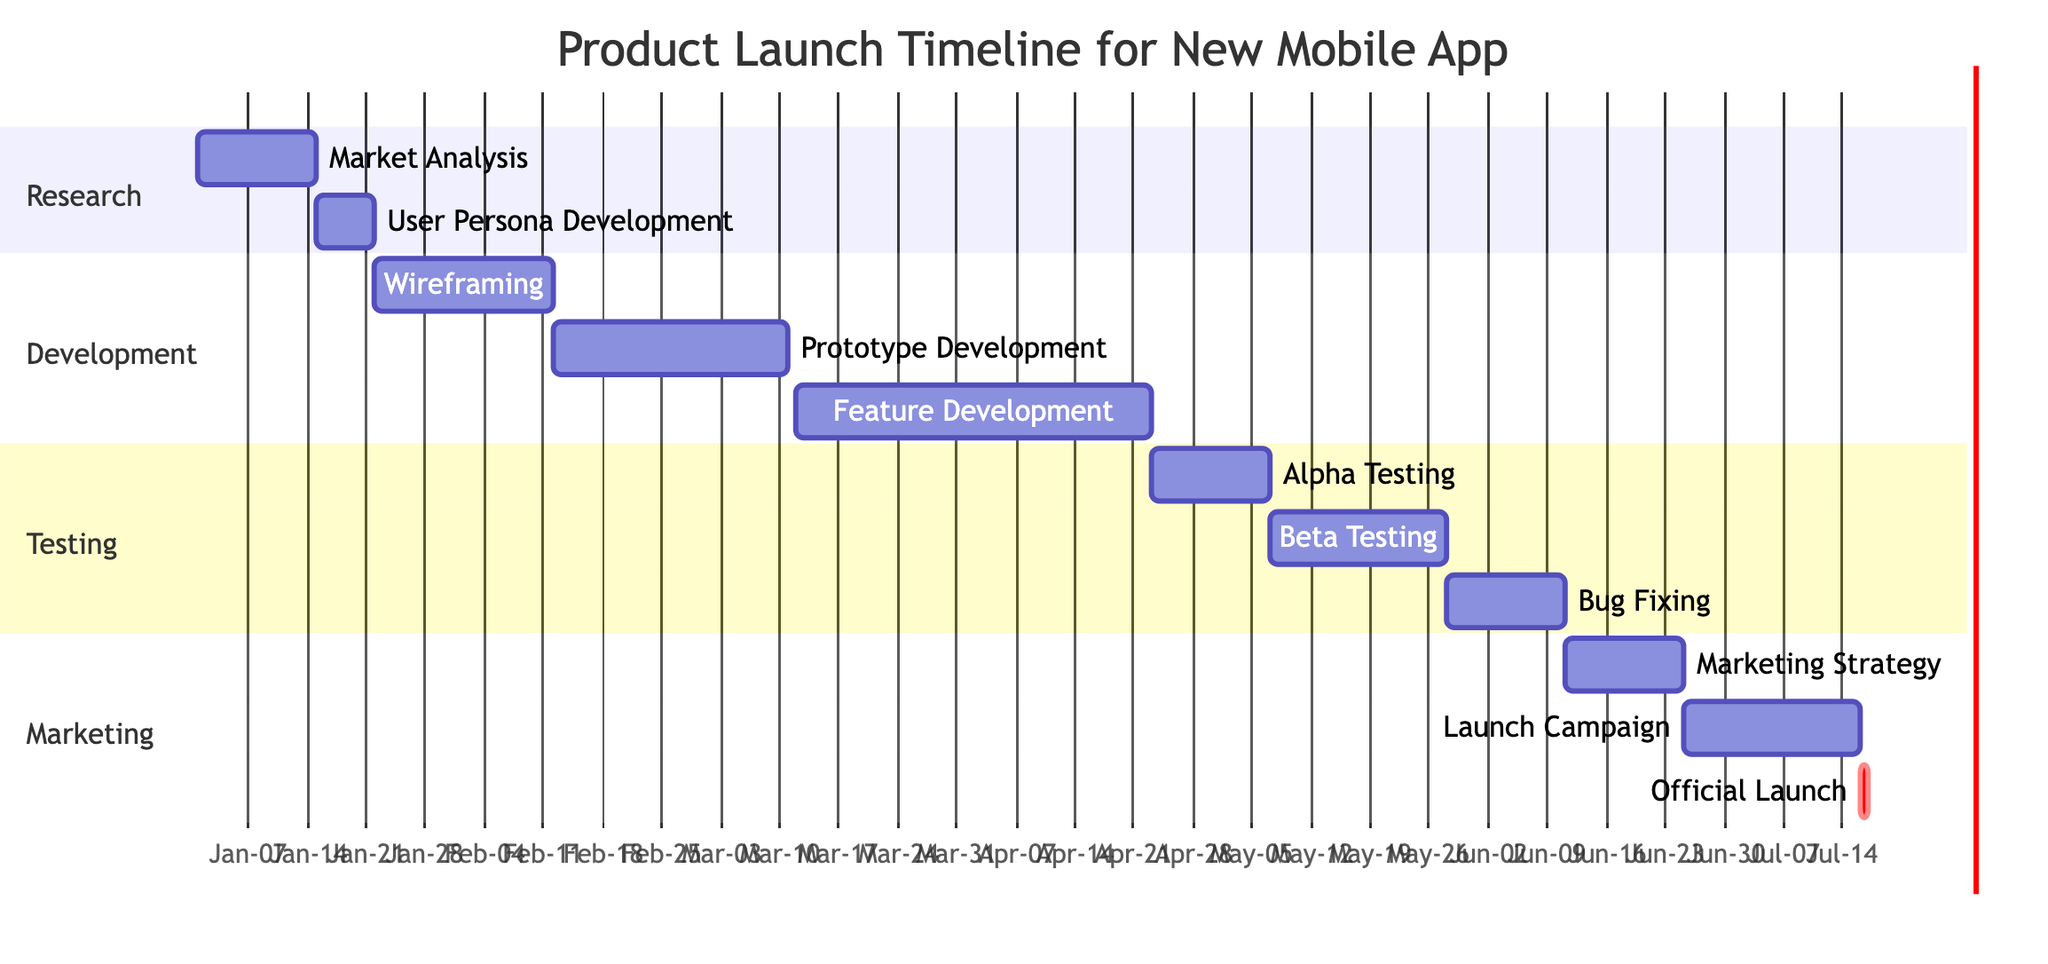What are the phases in the product launch timeline? The Gantt chart outlines four main phases: Research, Development, Testing, and Marketing.
Answer: Research, Development, Testing, Marketing During which phase does Alpha Testing occur? Looking at the timeline, Alpha Testing is listed under the Testing phase, starting on April 23, 2024 and ending on May 6, 2024.
Answer: Testing What is the duration of the Feature Development task? The Feature Development task in the Development phase is shown to have a duration of 6 weeks, beginning on March 12, 2024 and ending on April 22, 2024.
Answer: 6 weeks How many weeks does the Marketing Strategy Development take? The chart indicates that Marketing Strategy Development takes 2 weeks, starting from June 11, 2024 to June 24, 2024.
Answer: 2 weeks Which task has the earliest start date? The task Market Analysis has the earliest start date of January 1, 2024, as seen in the Research phase.
Answer: Market Analysis What is the end date for the Official Launch? The Official Launch is marked to take place on July 16, 2024, as indicated in the Marketing phase.
Answer: July 16, 2024 Which development task directly follows Wireframing? Reviewing the Development section, the task that directly follows Wireframing is Prototype Development, which begins on February 12, 2024.
Answer: Prototype Development How many tasks are included in the Testing phase? Counting the tasks listed under the Testing phase, there are three tasks: Alpha Testing, Beta Testing, and Bug Fixing.
Answer: 3 When does the Launch Campaign Preparation start? The Launch Campaign Preparation starts on June 25, 2024, as outlined in the Marketing section of the Gantt chart.
Answer: June 25, 2024 